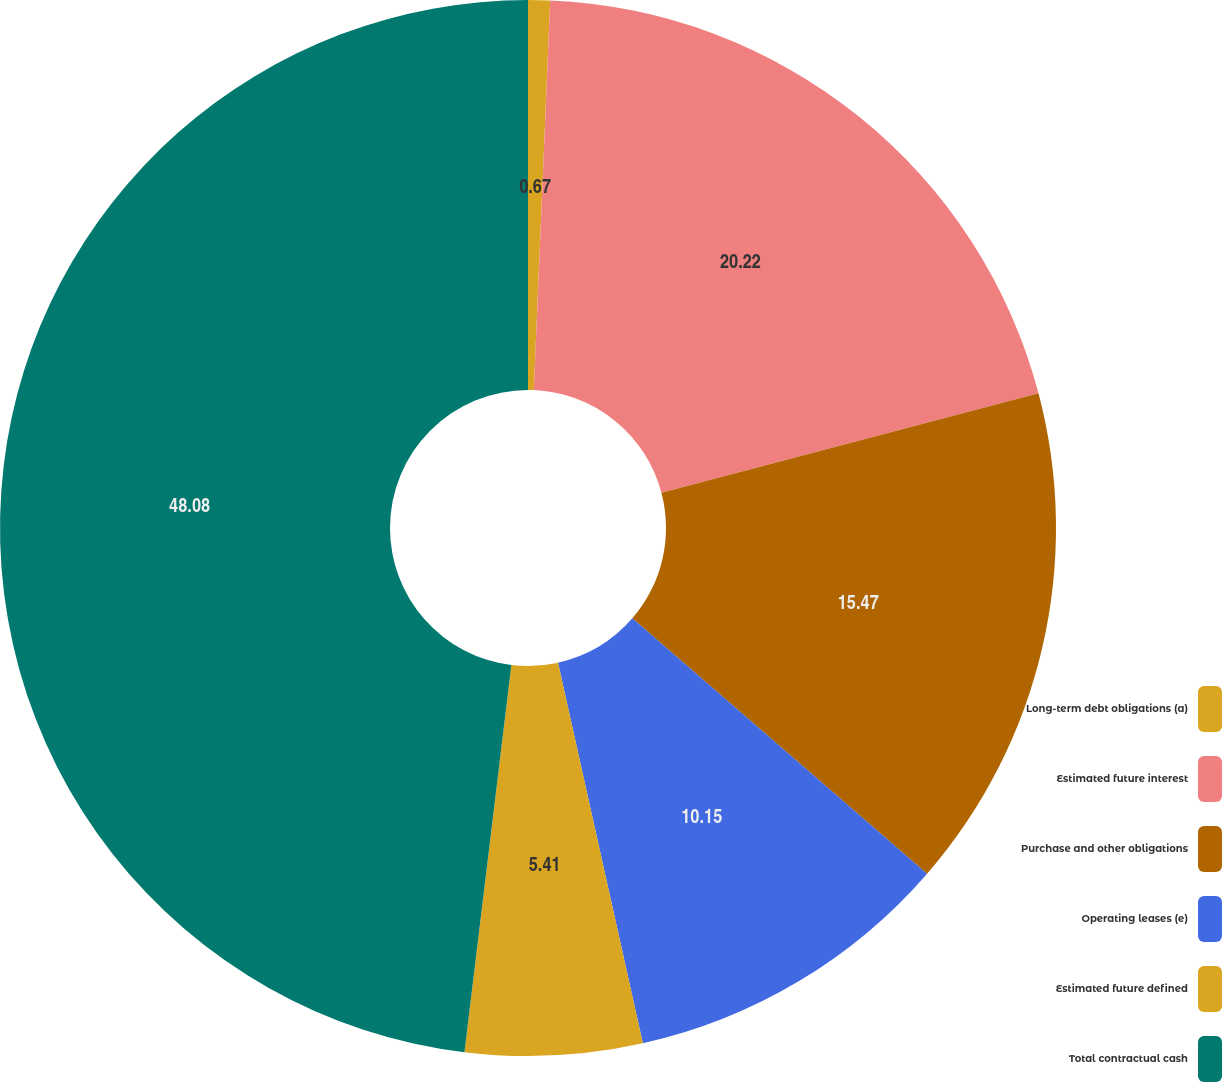<chart> <loc_0><loc_0><loc_500><loc_500><pie_chart><fcel>Long-term debt obligations (a)<fcel>Estimated future interest<fcel>Purchase and other obligations<fcel>Operating leases (e)<fcel>Estimated future defined<fcel>Total contractual cash<nl><fcel>0.67%<fcel>20.22%<fcel>15.47%<fcel>10.15%<fcel>5.41%<fcel>48.08%<nl></chart> 